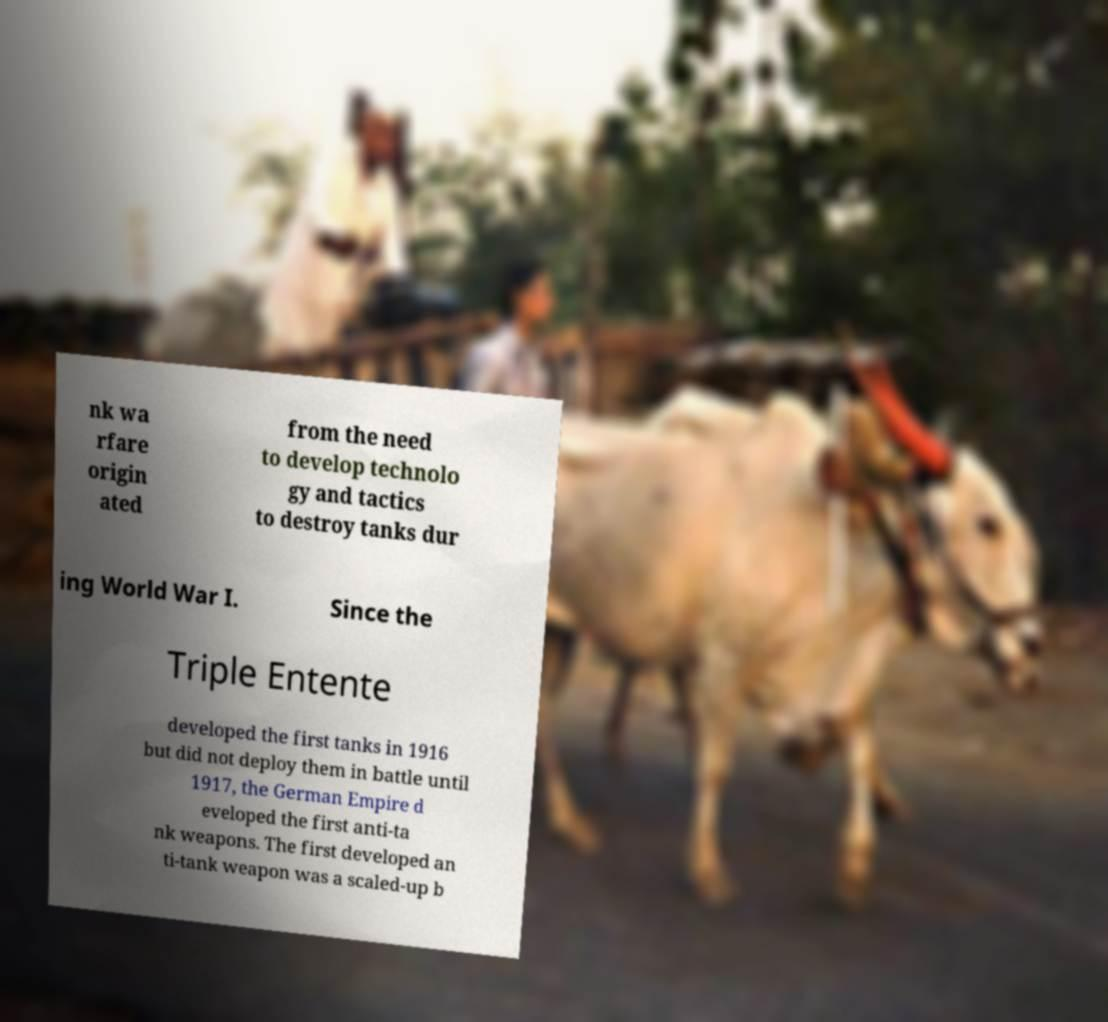There's text embedded in this image that I need extracted. Can you transcribe it verbatim? nk wa rfare origin ated from the need to develop technolo gy and tactics to destroy tanks dur ing World War I. Since the Triple Entente developed the first tanks in 1916 but did not deploy them in battle until 1917, the German Empire d eveloped the first anti-ta nk weapons. The first developed an ti-tank weapon was a scaled-up b 